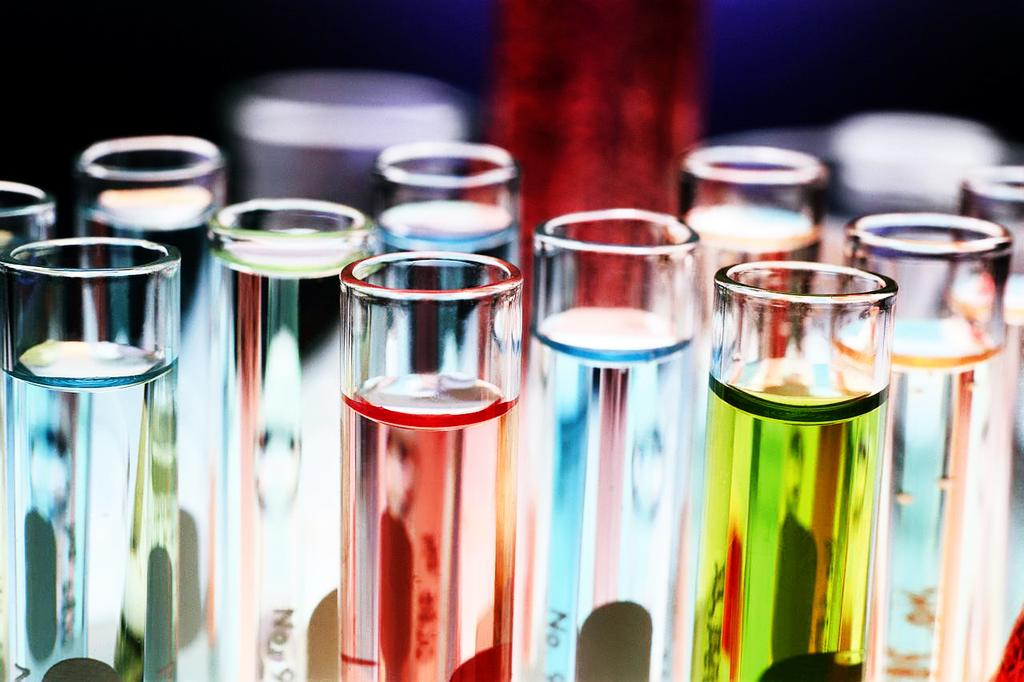<image>
Share a concise interpretation of the image provided. Several chemistry tubes with various colored liquids labeled with various numbers including No 9. 